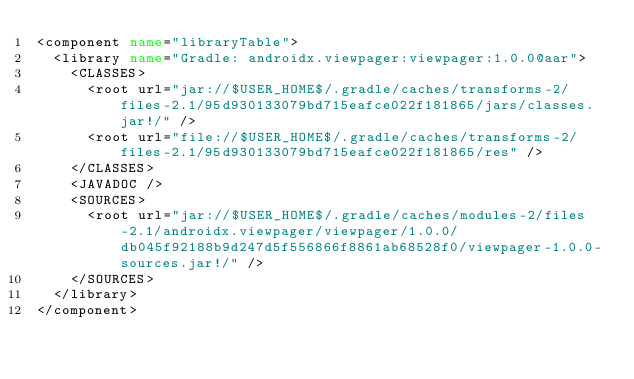Convert code to text. <code><loc_0><loc_0><loc_500><loc_500><_XML_><component name="libraryTable">
  <library name="Gradle: androidx.viewpager:viewpager:1.0.0@aar">
    <CLASSES>
      <root url="jar://$USER_HOME$/.gradle/caches/transforms-2/files-2.1/95d930133079bd715eafce022f181865/jars/classes.jar!/" />
      <root url="file://$USER_HOME$/.gradle/caches/transforms-2/files-2.1/95d930133079bd715eafce022f181865/res" />
    </CLASSES>
    <JAVADOC />
    <SOURCES>
      <root url="jar://$USER_HOME$/.gradle/caches/modules-2/files-2.1/androidx.viewpager/viewpager/1.0.0/db045f92188b9d247d5f556866f8861ab68528f0/viewpager-1.0.0-sources.jar!/" />
    </SOURCES>
  </library>
</component></code> 